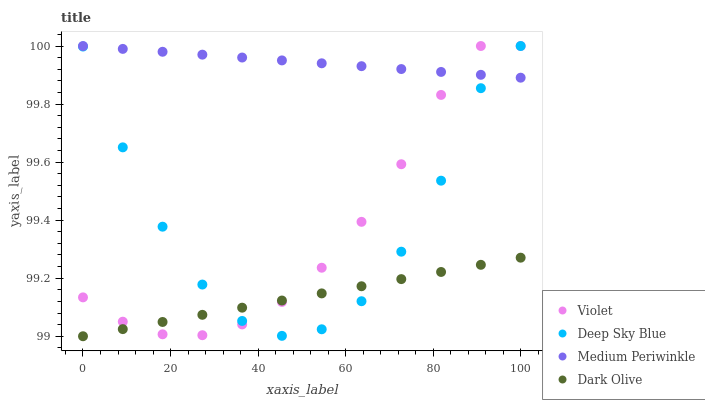Does Dark Olive have the minimum area under the curve?
Answer yes or no. Yes. Does Medium Periwinkle have the maximum area under the curve?
Answer yes or no. Yes. Does Deep Sky Blue have the minimum area under the curve?
Answer yes or no. No. Does Deep Sky Blue have the maximum area under the curve?
Answer yes or no. No. Is Dark Olive the smoothest?
Answer yes or no. Yes. Is Deep Sky Blue the roughest?
Answer yes or no. Yes. Is Medium Periwinkle the smoothest?
Answer yes or no. No. Is Medium Periwinkle the roughest?
Answer yes or no. No. Does Dark Olive have the lowest value?
Answer yes or no. Yes. Does Deep Sky Blue have the lowest value?
Answer yes or no. No. Does Violet have the highest value?
Answer yes or no. Yes. Is Dark Olive less than Medium Periwinkle?
Answer yes or no. Yes. Is Medium Periwinkle greater than Dark Olive?
Answer yes or no. Yes. Does Violet intersect Deep Sky Blue?
Answer yes or no. Yes. Is Violet less than Deep Sky Blue?
Answer yes or no. No. Is Violet greater than Deep Sky Blue?
Answer yes or no. No. Does Dark Olive intersect Medium Periwinkle?
Answer yes or no. No. 